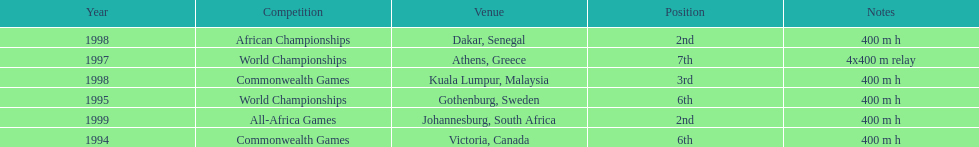What is the name of the last competition? All-Africa Games. 